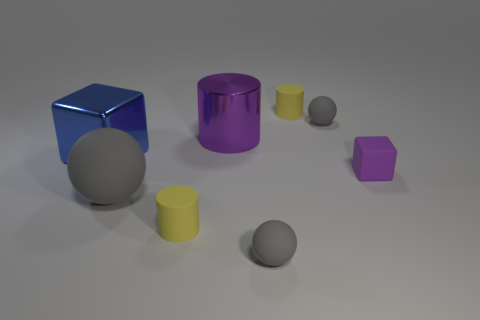How many gray spheres must be subtracted to get 1 gray spheres? 2 Subtract all small yellow matte cylinders. How many cylinders are left? 1 Subtract all purple cylinders. How many cylinders are left? 2 Add 1 rubber objects. How many objects exist? 9 Subtract 0 red cubes. How many objects are left? 8 Subtract all spheres. How many objects are left? 5 Subtract 2 balls. How many balls are left? 1 Subtract all green cylinders. Subtract all yellow balls. How many cylinders are left? 3 Subtract all purple cubes. How many yellow cylinders are left? 2 Subtract all purple metal cylinders. Subtract all large blue things. How many objects are left? 6 